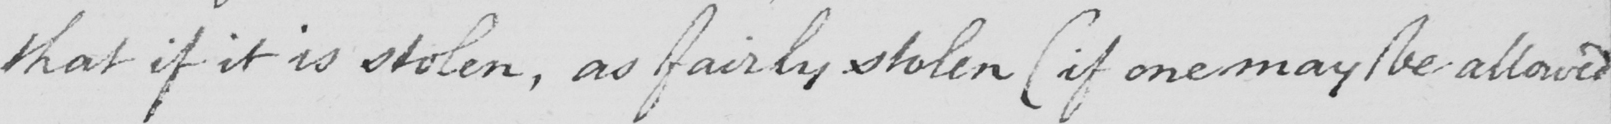Please transcribe the handwritten text in this image. that if it is stolen , as fairly stolen  ( if it may be allowed 